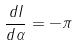<formula> <loc_0><loc_0><loc_500><loc_500>\frac { d I } { d \alpha } = - \pi</formula> 